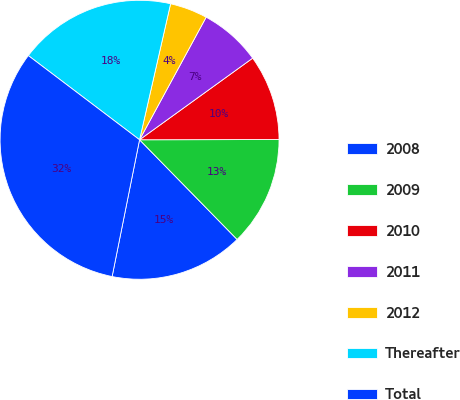<chart> <loc_0><loc_0><loc_500><loc_500><pie_chart><fcel>2008<fcel>2009<fcel>2010<fcel>2011<fcel>2012<fcel>Thereafter<fcel>Total<nl><fcel>15.48%<fcel>12.7%<fcel>9.92%<fcel>7.13%<fcel>4.35%<fcel>18.26%<fcel>32.16%<nl></chart> 